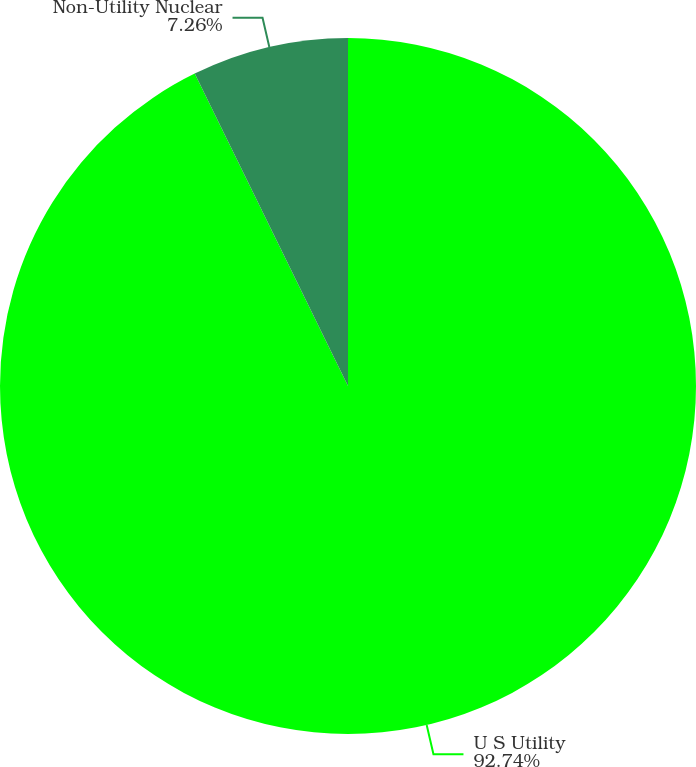Convert chart to OTSL. <chart><loc_0><loc_0><loc_500><loc_500><pie_chart><fcel>U S Utility<fcel>Non-Utility Nuclear<nl><fcel>92.74%<fcel>7.26%<nl></chart> 